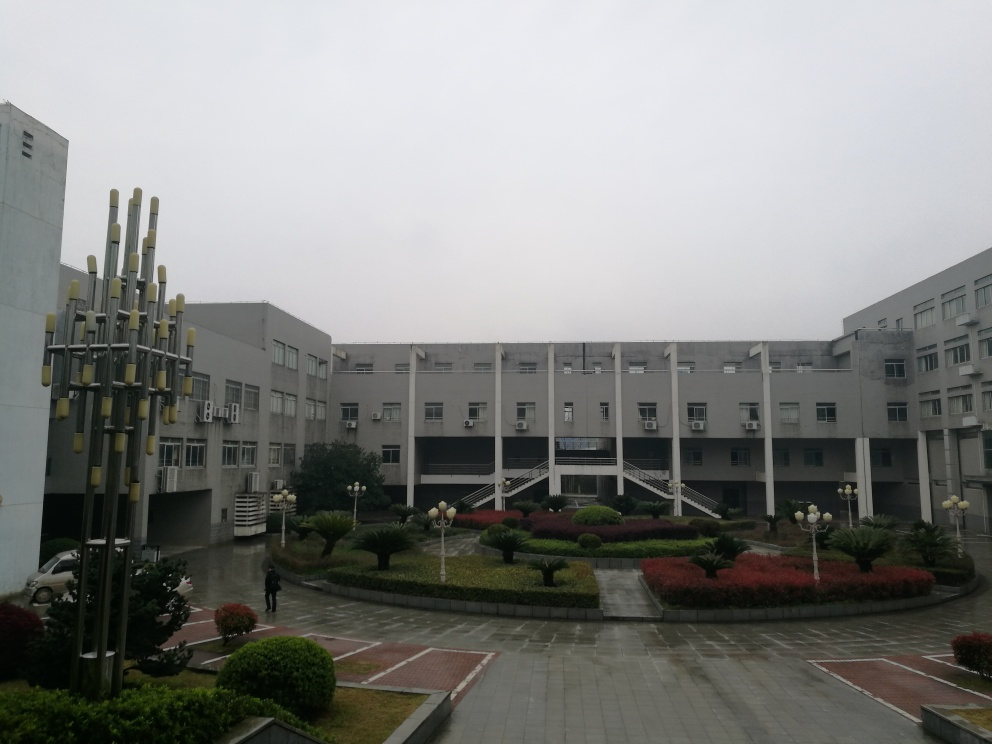Describe the landscaping seen in the image. The landscaping in the image includes well-maintained shrubs, arranged in neat rows with mulched garden beds. The presence of stairs and a central walkway implies that the area is designed to be pedestrian-friendly. The choice of plants and their arrangement suggest an intent to create a pleasing, orderly environment likely for a campus or public building. 